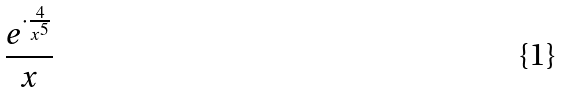<formula> <loc_0><loc_0><loc_500><loc_500>\frac { e ^ { \cdot \frac { 4 } { x ^ { 5 } } } } { x }</formula> 